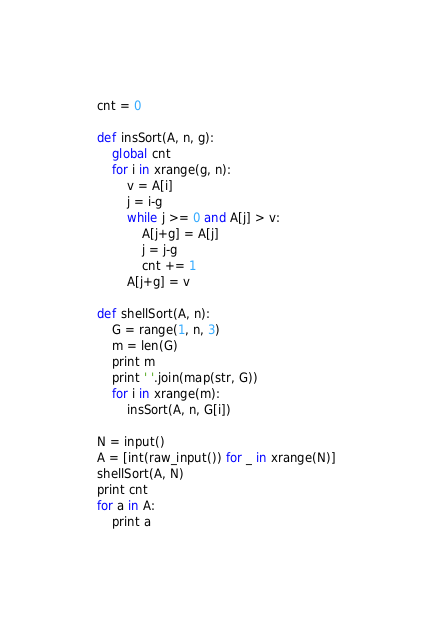Convert code to text. <code><loc_0><loc_0><loc_500><loc_500><_Python_>cnt = 0

def insSort(A, n, g):
    global cnt
    for i in xrange(g, n):
        v = A[i]
        j = i-g
        while j >= 0 and A[j] > v:
            A[j+g] = A[j]
            j = j-g
            cnt += 1
        A[j+g] = v

def shellSort(A, n):
    G = range(1, n, 3)
    m = len(G)
    print m
    print ' '.join(map(str, G))
    for i in xrange(m):
        insSort(A, n, G[i])

N = input()
A = [int(raw_input()) for _ in xrange(N)]
shellSort(A, N)
print cnt
for a in A:
    print a</code> 